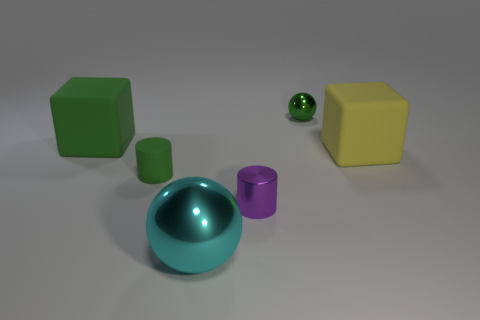Subtract 1 purple cylinders. How many objects are left? 5 Subtract all red cubes. Subtract all blue balls. How many cubes are left? 2 Subtract all green balls. How many cyan blocks are left? 0 Subtract all big cyan objects. Subtract all big gray objects. How many objects are left? 5 Add 1 yellow blocks. How many yellow blocks are left? 2 Add 3 small metallic cylinders. How many small metallic cylinders exist? 4 Add 1 small purple metal objects. How many objects exist? 7 Subtract all green cylinders. How many cylinders are left? 1 